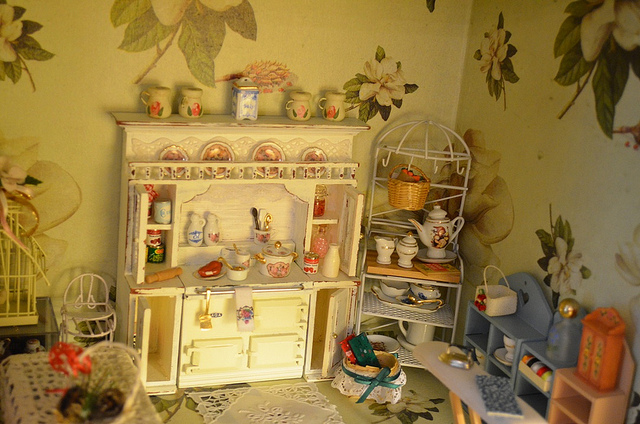Can you describe the setting displayed in the image? The image showcases a meticulously arranged dollhouse interior, resembling a vintage kitchen or a cozy dining space. It contains miniature furniture, including a cupboard filled with tiny dishes and faux food items, a small table, and even a miniature basket. 